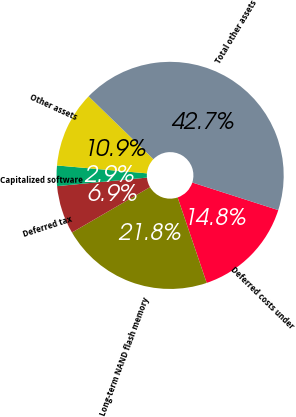Convert chart to OTSL. <chart><loc_0><loc_0><loc_500><loc_500><pie_chart><fcel>Deferred costs under<fcel>Long-term NAND flash memory<fcel>Deferred tax<fcel>Capitalized software<fcel>Other assets<fcel>Total other assets<nl><fcel>14.84%<fcel>21.83%<fcel>6.88%<fcel>2.9%<fcel>10.86%<fcel>42.69%<nl></chart> 